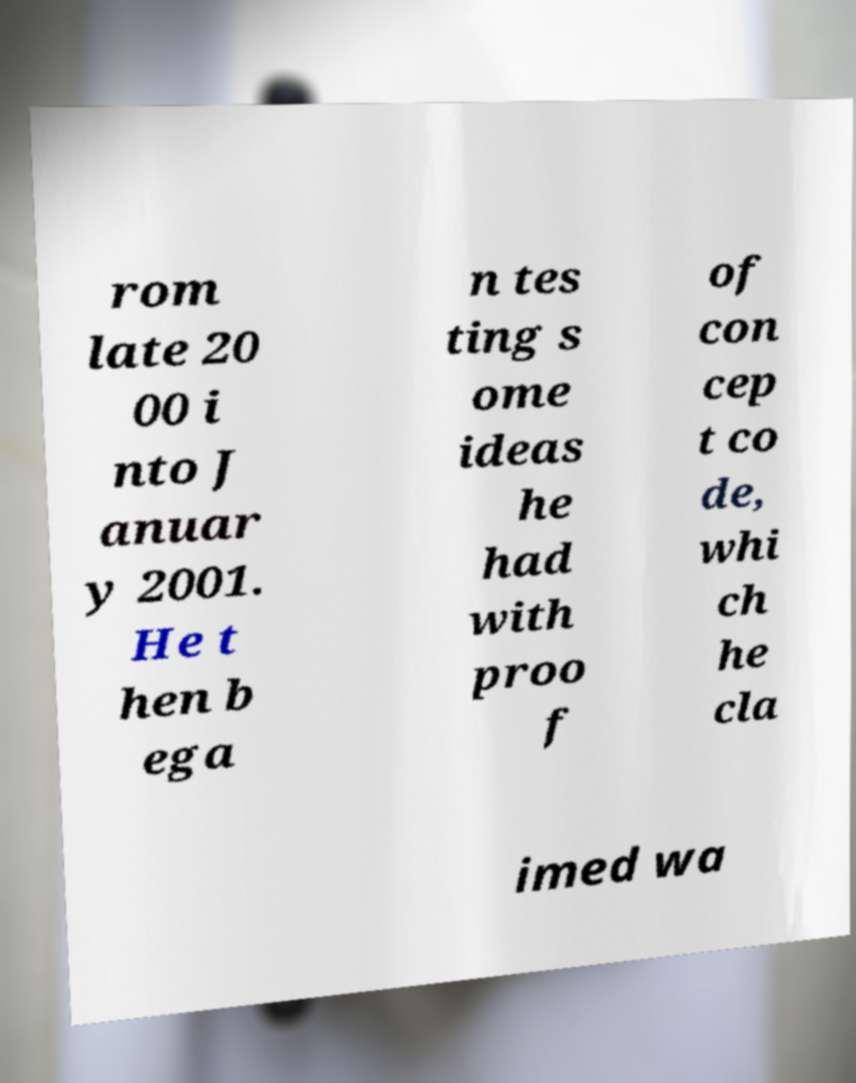Could you assist in decoding the text presented in this image and type it out clearly? rom late 20 00 i nto J anuar y 2001. He t hen b ega n tes ting s ome ideas he had with proo f of con cep t co de, whi ch he cla imed wa 